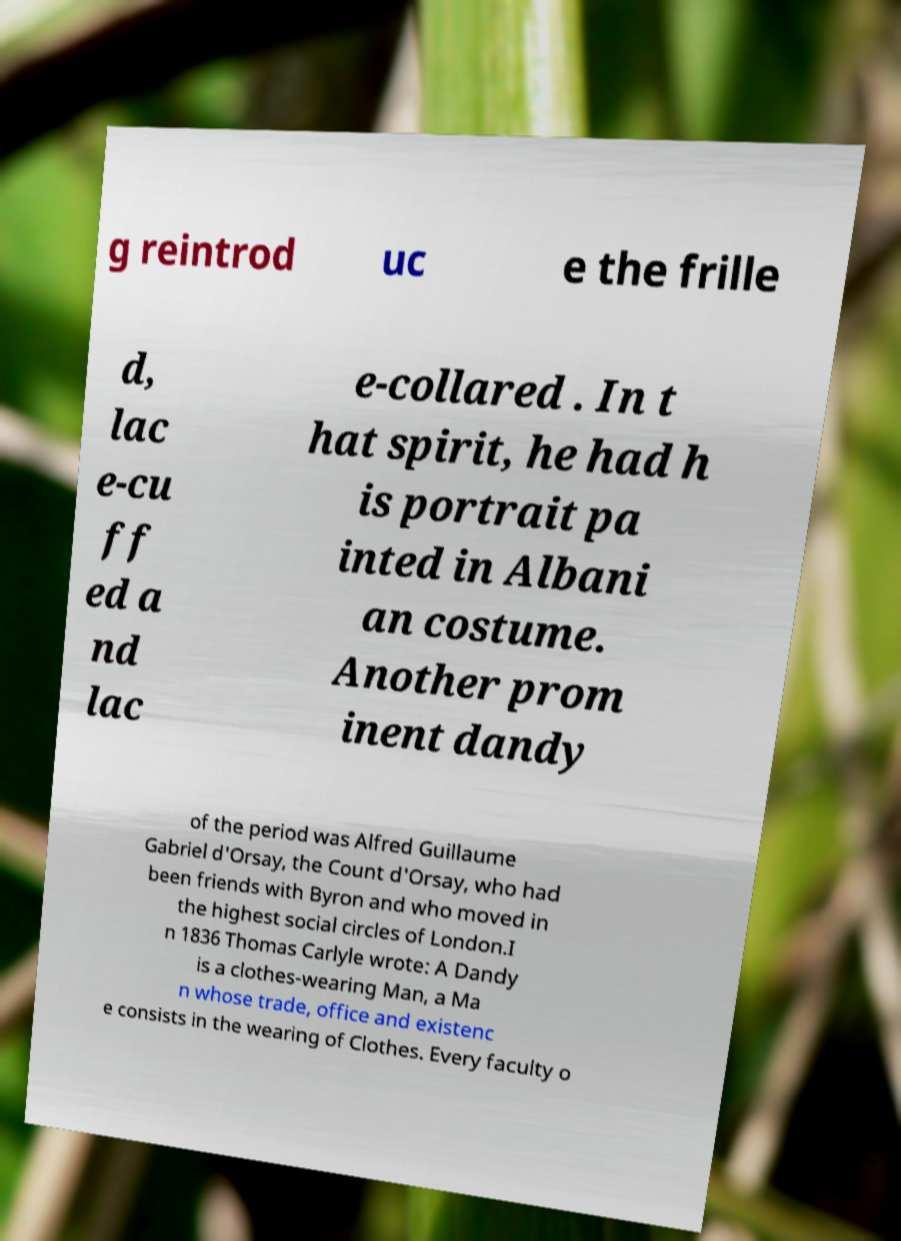Could you assist in decoding the text presented in this image and type it out clearly? g reintrod uc e the frille d, lac e-cu ff ed a nd lac e-collared . In t hat spirit, he had h is portrait pa inted in Albani an costume. Another prom inent dandy of the period was Alfred Guillaume Gabriel d'Orsay, the Count d'Orsay, who had been friends with Byron and who moved in the highest social circles of London.I n 1836 Thomas Carlyle wrote: A Dandy is a clothes-wearing Man, a Ma n whose trade, office and existenc e consists in the wearing of Clothes. Every faculty o 